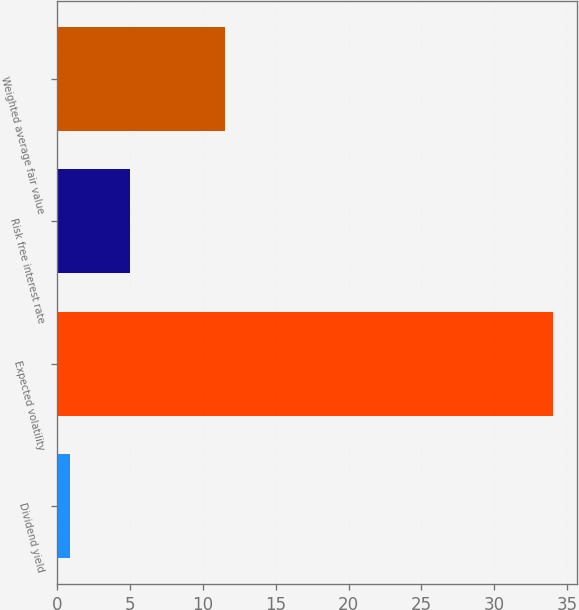<chart> <loc_0><loc_0><loc_500><loc_500><bar_chart><fcel>Dividend yield<fcel>Expected volatility<fcel>Risk free interest rate<fcel>Weighted average fair value<nl><fcel>0.9<fcel>34<fcel>5<fcel>11.52<nl></chart> 